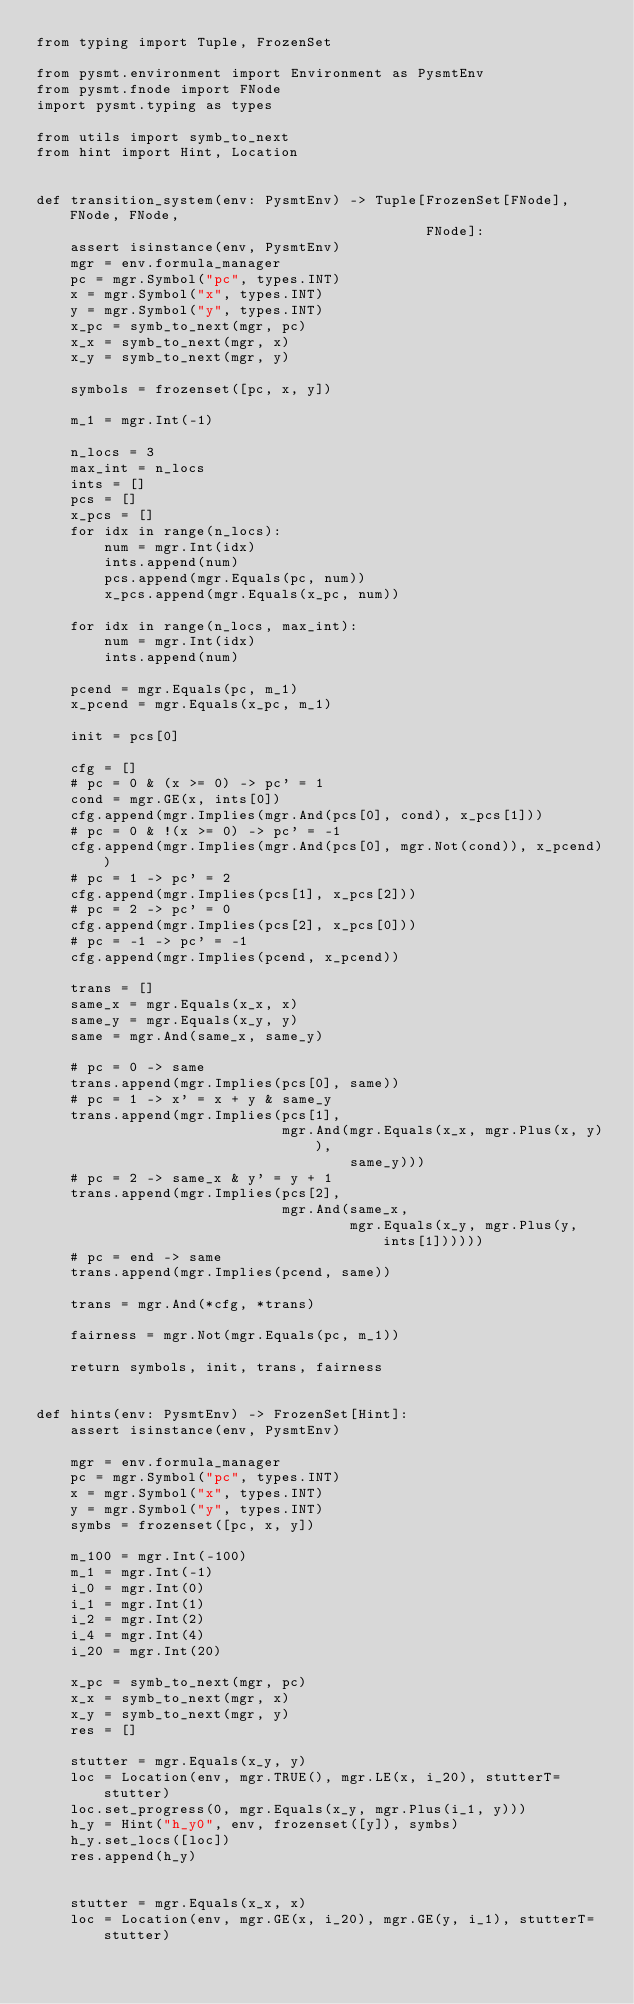<code> <loc_0><loc_0><loc_500><loc_500><_Python_>from typing import Tuple, FrozenSet

from pysmt.environment import Environment as PysmtEnv
from pysmt.fnode import FNode
import pysmt.typing as types

from utils import symb_to_next
from hint import Hint, Location


def transition_system(env: PysmtEnv) -> Tuple[FrozenSet[FNode], FNode, FNode,
                                              FNode]:
    assert isinstance(env, PysmtEnv)
    mgr = env.formula_manager
    pc = mgr.Symbol("pc", types.INT)
    x = mgr.Symbol("x", types.INT)
    y = mgr.Symbol("y", types.INT)
    x_pc = symb_to_next(mgr, pc)
    x_x = symb_to_next(mgr, x)
    x_y = symb_to_next(mgr, y)

    symbols = frozenset([pc, x, y])

    m_1 = mgr.Int(-1)

    n_locs = 3
    max_int = n_locs
    ints = []
    pcs = []
    x_pcs = []
    for idx in range(n_locs):
        num = mgr.Int(idx)
        ints.append(num)
        pcs.append(mgr.Equals(pc, num))
        x_pcs.append(mgr.Equals(x_pc, num))

    for idx in range(n_locs, max_int):
        num = mgr.Int(idx)
        ints.append(num)

    pcend = mgr.Equals(pc, m_1)
    x_pcend = mgr.Equals(x_pc, m_1)

    init = pcs[0]

    cfg = []
    # pc = 0 & (x >= 0) -> pc' = 1
    cond = mgr.GE(x, ints[0])
    cfg.append(mgr.Implies(mgr.And(pcs[0], cond), x_pcs[1]))
    # pc = 0 & !(x >= 0) -> pc' = -1
    cfg.append(mgr.Implies(mgr.And(pcs[0], mgr.Not(cond)), x_pcend))
    # pc = 1 -> pc' = 2
    cfg.append(mgr.Implies(pcs[1], x_pcs[2]))
    # pc = 2 -> pc' = 0
    cfg.append(mgr.Implies(pcs[2], x_pcs[0]))
    # pc = -1 -> pc' = -1
    cfg.append(mgr.Implies(pcend, x_pcend))

    trans = []
    same_x = mgr.Equals(x_x, x)
    same_y = mgr.Equals(x_y, y)
    same = mgr.And(same_x, same_y)

    # pc = 0 -> same
    trans.append(mgr.Implies(pcs[0], same))
    # pc = 1 -> x' = x + y & same_y
    trans.append(mgr.Implies(pcs[1],
                             mgr.And(mgr.Equals(x_x, mgr.Plus(x, y)),
                                     same_y)))
    # pc = 2 -> same_x & y' = y + 1
    trans.append(mgr.Implies(pcs[2],
                             mgr.And(same_x,
                                     mgr.Equals(x_y, mgr.Plus(y, ints[1])))))
    # pc = end -> same
    trans.append(mgr.Implies(pcend, same))

    trans = mgr.And(*cfg, *trans)

    fairness = mgr.Not(mgr.Equals(pc, m_1))

    return symbols, init, trans, fairness


def hints(env: PysmtEnv) -> FrozenSet[Hint]:
    assert isinstance(env, PysmtEnv)

    mgr = env.formula_manager
    pc = mgr.Symbol("pc", types.INT)
    x = mgr.Symbol("x", types.INT)
    y = mgr.Symbol("y", types.INT)
    symbs = frozenset([pc, x, y])

    m_100 = mgr.Int(-100)
    m_1 = mgr.Int(-1)
    i_0 = mgr.Int(0)
    i_1 = mgr.Int(1)
    i_2 = mgr.Int(2)
    i_4 = mgr.Int(4)
    i_20 = mgr.Int(20)

    x_pc = symb_to_next(mgr, pc)
    x_x = symb_to_next(mgr, x)
    x_y = symb_to_next(mgr, y)
    res = []

    stutter = mgr.Equals(x_y, y)
    loc = Location(env, mgr.TRUE(), mgr.LE(x, i_20), stutterT=stutter)
    loc.set_progress(0, mgr.Equals(x_y, mgr.Plus(i_1, y)))
    h_y = Hint("h_y0", env, frozenset([y]), symbs)
    h_y.set_locs([loc])
    res.append(h_y)


    stutter = mgr.Equals(x_x, x)
    loc = Location(env, mgr.GE(x, i_20), mgr.GE(y, i_1), stutterT=stutter)</code> 